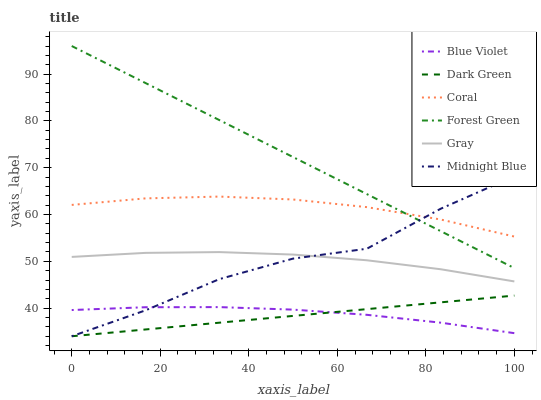Does Dark Green have the minimum area under the curve?
Answer yes or no. Yes. Does Forest Green have the maximum area under the curve?
Answer yes or no. Yes. Does Midnight Blue have the minimum area under the curve?
Answer yes or no. No. Does Midnight Blue have the maximum area under the curve?
Answer yes or no. No. Is Dark Green the smoothest?
Answer yes or no. Yes. Is Midnight Blue the roughest?
Answer yes or no. Yes. Is Coral the smoothest?
Answer yes or no. No. Is Coral the roughest?
Answer yes or no. No. Does Midnight Blue have the lowest value?
Answer yes or no. Yes. Does Coral have the lowest value?
Answer yes or no. No. Does Forest Green have the highest value?
Answer yes or no. Yes. Does Midnight Blue have the highest value?
Answer yes or no. No. Is Gray less than Coral?
Answer yes or no. Yes. Is Coral greater than Blue Violet?
Answer yes or no. Yes. Does Forest Green intersect Midnight Blue?
Answer yes or no. Yes. Is Forest Green less than Midnight Blue?
Answer yes or no. No. Is Forest Green greater than Midnight Blue?
Answer yes or no. No. Does Gray intersect Coral?
Answer yes or no. No. 